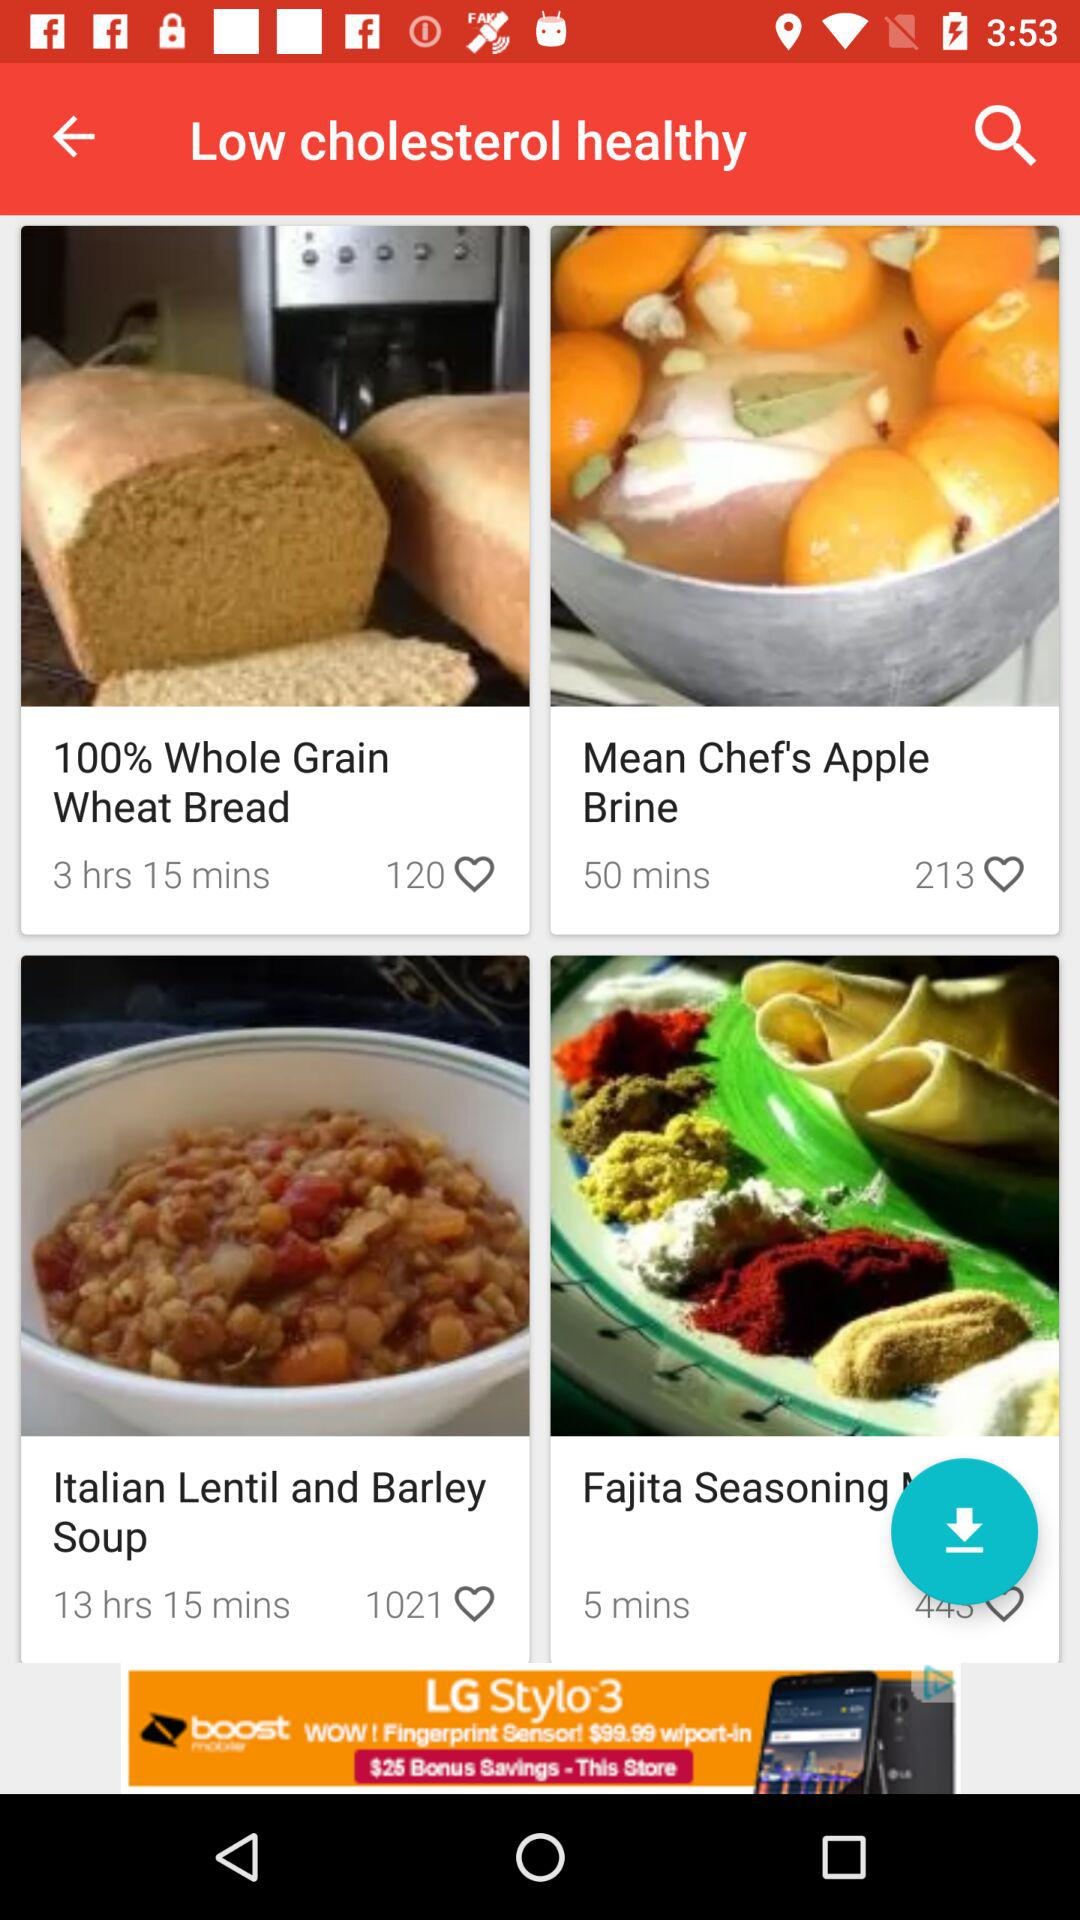What is the cooking time of whole grain wheat bread? The cooking time is 3 hours and 15 minutes. 